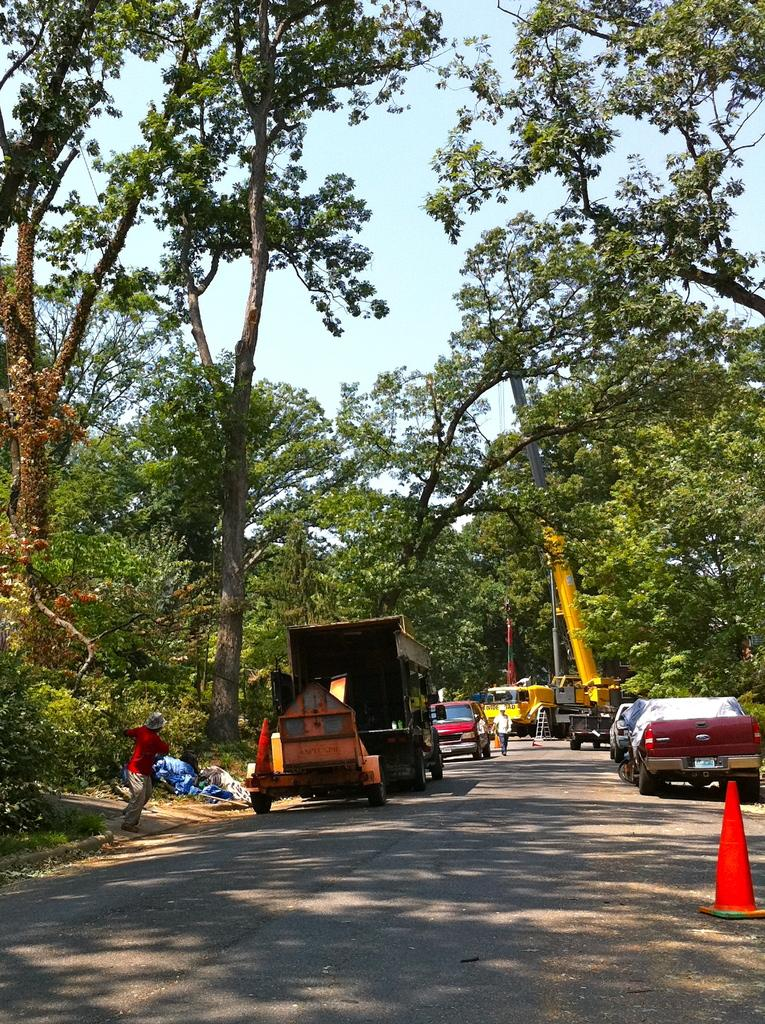What can be seen in the sky in the image? The sky is visible in the image. What type of natural elements are present in the image? There are trees in the image. Are there any people in the image? Yes, there are persons in the image. What type of man-made objects can be seen in the image? Motor vehicles are present in the image. What safety measures are in place on the road in the image? Traffic cones are on the road in the image. Can you see any toads swimming in the image? There are no toads or swimming activity present in the image. What type of shoe is being worn by the person in the image? There is no person wearing a shoe in the image; the persons are not visible in enough detail to determine their footwear. 